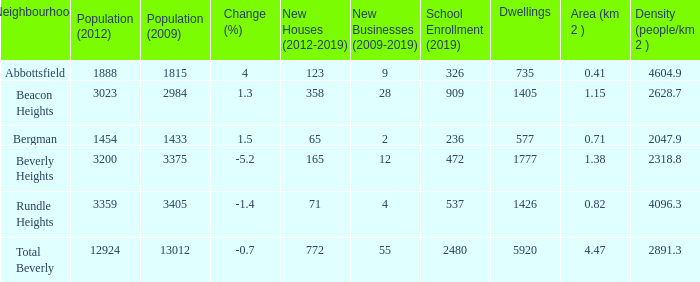How many homes in beverly heights have a change rate higher than - None. 